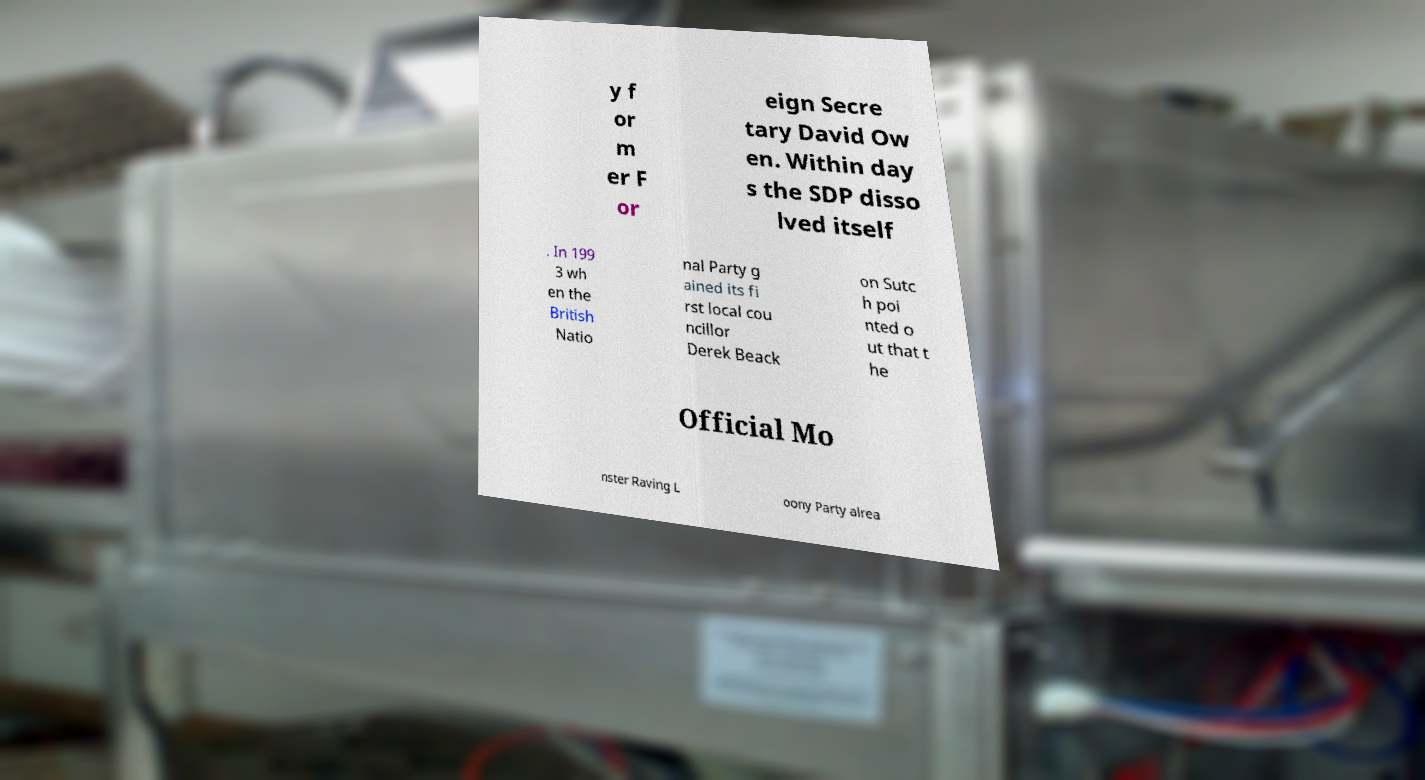Can you accurately transcribe the text from the provided image for me? y f or m er F or eign Secre tary David Ow en. Within day s the SDP disso lved itself . In 199 3 wh en the British Natio nal Party g ained its fi rst local cou ncillor Derek Beack on Sutc h poi nted o ut that t he Official Mo nster Raving L oony Party alrea 